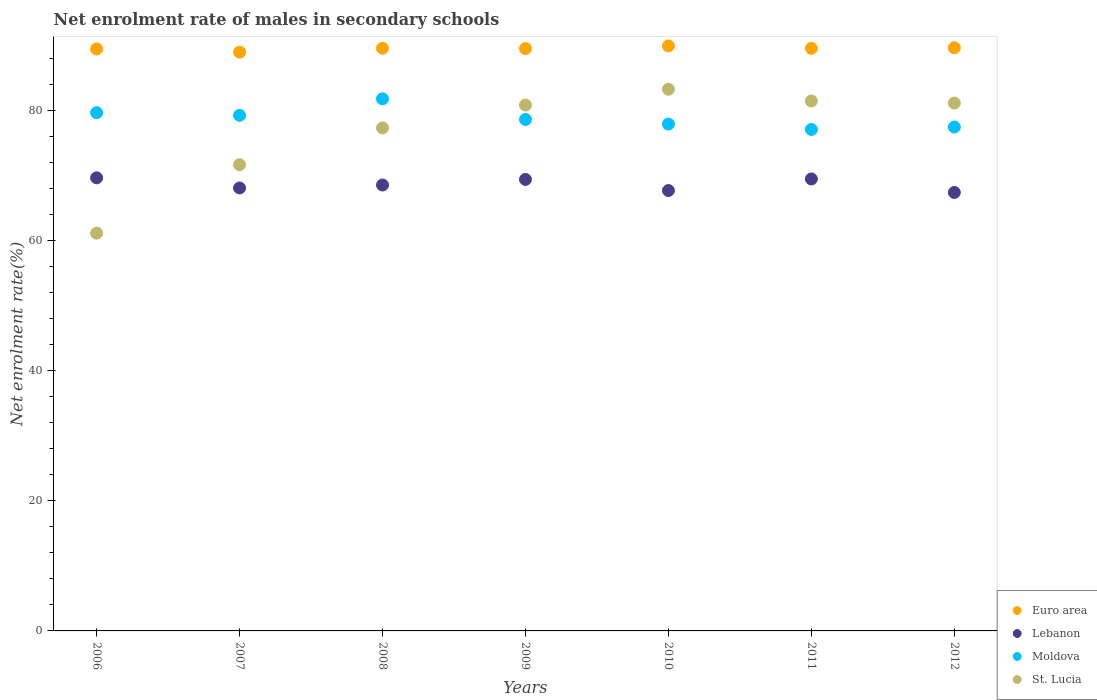Is the number of dotlines equal to the number of legend labels?
Your answer should be very brief. Yes. What is the net enrolment rate of males in secondary schools in Moldova in 2006?
Ensure brevity in your answer.  79.71. Across all years, what is the maximum net enrolment rate of males in secondary schools in Moldova?
Your response must be concise. 81.84. Across all years, what is the minimum net enrolment rate of males in secondary schools in Moldova?
Give a very brief answer. 77.13. What is the total net enrolment rate of males in secondary schools in St. Lucia in the graph?
Offer a very short reply. 537.16. What is the difference between the net enrolment rate of males in secondary schools in St. Lucia in 2007 and that in 2011?
Provide a short and direct response. -9.8. What is the difference between the net enrolment rate of males in secondary schools in Moldova in 2012 and the net enrolment rate of males in secondary schools in St. Lucia in 2010?
Your answer should be compact. -5.82. What is the average net enrolment rate of males in secondary schools in Euro area per year?
Offer a terse response. 89.57. In the year 2009, what is the difference between the net enrolment rate of males in secondary schools in St. Lucia and net enrolment rate of males in secondary schools in Lebanon?
Offer a very short reply. 11.44. What is the ratio of the net enrolment rate of males in secondary schools in Moldova in 2006 to that in 2008?
Your answer should be very brief. 0.97. Is the net enrolment rate of males in secondary schools in Moldova in 2006 less than that in 2011?
Your answer should be compact. No. Is the difference between the net enrolment rate of males in secondary schools in St. Lucia in 2006 and 2011 greater than the difference between the net enrolment rate of males in secondary schools in Lebanon in 2006 and 2011?
Keep it short and to the point. No. What is the difference between the highest and the second highest net enrolment rate of males in secondary schools in St. Lucia?
Provide a short and direct response. 1.81. What is the difference between the highest and the lowest net enrolment rate of males in secondary schools in St. Lucia?
Offer a terse response. 22.14. Is it the case that in every year, the sum of the net enrolment rate of males in secondary schools in Euro area and net enrolment rate of males in secondary schools in Moldova  is greater than the sum of net enrolment rate of males in secondary schools in St. Lucia and net enrolment rate of males in secondary schools in Lebanon?
Your answer should be very brief. Yes. Is it the case that in every year, the sum of the net enrolment rate of males in secondary schools in Lebanon and net enrolment rate of males in secondary schools in St. Lucia  is greater than the net enrolment rate of males in secondary schools in Euro area?
Ensure brevity in your answer.  Yes. Does the net enrolment rate of males in secondary schools in Lebanon monotonically increase over the years?
Your answer should be very brief. No. How many dotlines are there?
Your answer should be compact. 4. Does the graph contain any zero values?
Provide a short and direct response. No. How many legend labels are there?
Provide a succinct answer. 4. What is the title of the graph?
Provide a short and direct response. Net enrolment rate of males in secondary schools. Does "Dominica" appear as one of the legend labels in the graph?
Keep it short and to the point. No. What is the label or title of the Y-axis?
Keep it short and to the point. Net enrolment rate(%). What is the Net enrolment rate(%) of Euro area in 2006?
Provide a short and direct response. 89.52. What is the Net enrolment rate(%) in Lebanon in 2006?
Your answer should be very brief. 69.69. What is the Net enrolment rate(%) in Moldova in 2006?
Ensure brevity in your answer.  79.71. What is the Net enrolment rate(%) in St. Lucia in 2006?
Ensure brevity in your answer.  61.18. What is the Net enrolment rate(%) of Euro area in 2007?
Provide a short and direct response. 89.03. What is the Net enrolment rate(%) in Lebanon in 2007?
Keep it short and to the point. 68.13. What is the Net enrolment rate(%) of Moldova in 2007?
Ensure brevity in your answer.  79.3. What is the Net enrolment rate(%) in St. Lucia in 2007?
Provide a succinct answer. 71.71. What is the Net enrolment rate(%) of Euro area in 2008?
Offer a terse response. 89.62. What is the Net enrolment rate(%) in Lebanon in 2008?
Make the answer very short. 68.59. What is the Net enrolment rate(%) in Moldova in 2008?
Keep it short and to the point. 81.84. What is the Net enrolment rate(%) of St. Lucia in 2008?
Your answer should be compact. 77.37. What is the Net enrolment rate(%) in Euro area in 2009?
Your response must be concise. 89.57. What is the Net enrolment rate(%) of Lebanon in 2009?
Your answer should be very brief. 69.44. What is the Net enrolment rate(%) in Moldova in 2009?
Make the answer very short. 78.67. What is the Net enrolment rate(%) in St. Lucia in 2009?
Your answer should be very brief. 80.89. What is the Net enrolment rate(%) of Euro area in 2010?
Offer a very short reply. 89.98. What is the Net enrolment rate(%) in Lebanon in 2010?
Your answer should be very brief. 67.74. What is the Net enrolment rate(%) of Moldova in 2010?
Your answer should be compact. 77.96. What is the Net enrolment rate(%) of St. Lucia in 2010?
Your answer should be compact. 83.32. What is the Net enrolment rate(%) of Euro area in 2011?
Provide a succinct answer. 89.61. What is the Net enrolment rate(%) of Lebanon in 2011?
Ensure brevity in your answer.  69.52. What is the Net enrolment rate(%) of Moldova in 2011?
Provide a short and direct response. 77.13. What is the Net enrolment rate(%) in St. Lucia in 2011?
Offer a terse response. 81.51. What is the Net enrolment rate(%) of Euro area in 2012?
Offer a very short reply. 89.7. What is the Net enrolment rate(%) in Lebanon in 2012?
Make the answer very short. 67.44. What is the Net enrolment rate(%) in Moldova in 2012?
Provide a short and direct response. 77.5. What is the Net enrolment rate(%) in St. Lucia in 2012?
Ensure brevity in your answer.  81.19. Across all years, what is the maximum Net enrolment rate(%) in Euro area?
Provide a succinct answer. 89.98. Across all years, what is the maximum Net enrolment rate(%) in Lebanon?
Your response must be concise. 69.69. Across all years, what is the maximum Net enrolment rate(%) of Moldova?
Provide a succinct answer. 81.84. Across all years, what is the maximum Net enrolment rate(%) in St. Lucia?
Your response must be concise. 83.32. Across all years, what is the minimum Net enrolment rate(%) of Euro area?
Make the answer very short. 89.03. Across all years, what is the minimum Net enrolment rate(%) in Lebanon?
Provide a short and direct response. 67.44. Across all years, what is the minimum Net enrolment rate(%) in Moldova?
Offer a terse response. 77.13. Across all years, what is the minimum Net enrolment rate(%) of St. Lucia?
Make the answer very short. 61.18. What is the total Net enrolment rate(%) of Euro area in the graph?
Make the answer very short. 627.02. What is the total Net enrolment rate(%) in Lebanon in the graph?
Make the answer very short. 480.55. What is the total Net enrolment rate(%) of Moldova in the graph?
Ensure brevity in your answer.  552.12. What is the total Net enrolment rate(%) in St. Lucia in the graph?
Offer a very short reply. 537.16. What is the difference between the Net enrolment rate(%) in Euro area in 2006 and that in 2007?
Your answer should be very brief. 0.49. What is the difference between the Net enrolment rate(%) of Lebanon in 2006 and that in 2007?
Keep it short and to the point. 1.56. What is the difference between the Net enrolment rate(%) of Moldova in 2006 and that in 2007?
Offer a terse response. 0.41. What is the difference between the Net enrolment rate(%) of St. Lucia in 2006 and that in 2007?
Your response must be concise. -10.53. What is the difference between the Net enrolment rate(%) in Euro area in 2006 and that in 2008?
Your answer should be compact. -0.1. What is the difference between the Net enrolment rate(%) of Lebanon in 2006 and that in 2008?
Make the answer very short. 1.1. What is the difference between the Net enrolment rate(%) of Moldova in 2006 and that in 2008?
Ensure brevity in your answer.  -2.13. What is the difference between the Net enrolment rate(%) of St. Lucia in 2006 and that in 2008?
Your answer should be very brief. -16.19. What is the difference between the Net enrolment rate(%) of Euro area in 2006 and that in 2009?
Your answer should be compact. -0.06. What is the difference between the Net enrolment rate(%) in Lebanon in 2006 and that in 2009?
Your response must be concise. 0.25. What is the difference between the Net enrolment rate(%) of Moldova in 2006 and that in 2009?
Keep it short and to the point. 1.04. What is the difference between the Net enrolment rate(%) in St. Lucia in 2006 and that in 2009?
Your response must be concise. -19.71. What is the difference between the Net enrolment rate(%) in Euro area in 2006 and that in 2010?
Your answer should be compact. -0.46. What is the difference between the Net enrolment rate(%) in Lebanon in 2006 and that in 2010?
Your answer should be very brief. 1.96. What is the difference between the Net enrolment rate(%) of Moldova in 2006 and that in 2010?
Provide a short and direct response. 1.75. What is the difference between the Net enrolment rate(%) in St. Lucia in 2006 and that in 2010?
Your answer should be very brief. -22.14. What is the difference between the Net enrolment rate(%) in Euro area in 2006 and that in 2011?
Make the answer very short. -0.09. What is the difference between the Net enrolment rate(%) in Lebanon in 2006 and that in 2011?
Your answer should be very brief. 0.17. What is the difference between the Net enrolment rate(%) in Moldova in 2006 and that in 2011?
Your answer should be compact. 2.58. What is the difference between the Net enrolment rate(%) of St. Lucia in 2006 and that in 2011?
Keep it short and to the point. -20.32. What is the difference between the Net enrolment rate(%) in Euro area in 2006 and that in 2012?
Keep it short and to the point. -0.18. What is the difference between the Net enrolment rate(%) in Lebanon in 2006 and that in 2012?
Offer a terse response. 2.26. What is the difference between the Net enrolment rate(%) of Moldova in 2006 and that in 2012?
Keep it short and to the point. 2.21. What is the difference between the Net enrolment rate(%) of St. Lucia in 2006 and that in 2012?
Ensure brevity in your answer.  -20.01. What is the difference between the Net enrolment rate(%) in Euro area in 2007 and that in 2008?
Give a very brief answer. -0.59. What is the difference between the Net enrolment rate(%) in Lebanon in 2007 and that in 2008?
Give a very brief answer. -0.46. What is the difference between the Net enrolment rate(%) of Moldova in 2007 and that in 2008?
Offer a terse response. -2.54. What is the difference between the Net enrolment rate(%) of St. Lucia in 2007 and that in 2008?
Provide a succinct answer. -5.66. What is the difference between the Net enrolment rate(%) of Euro area in 2007 and that in 2009?
Your answer should be very brief. -0.55. What is the difference between the Net enrolment rate(%) in Lebanon in 2007 and that in 2009?
Provide a short and direct response. -1.31. What is the difference between the Net enrolment rate(%) in Moldova in 2007 and that in 2009?
Provide a succinct answer. 0.63. What is the difference between the Net enrolment rate(%) of St. Lucia in 2007 and that in 2009?
Your answer should be very brief. -9.18. What is the difference between the Net enrolment rate(%) in Euro area in 2007 and that in 2010?
Your response must be concise. -0.95. What is the difference between the Net enrolment rate(%) of Lebanon in 2007 and that in 2010?
Offer a very short reply. 0.4. What is the difference between the Net enrolment rate(%) of Moldova in 2007 and that in 2010?
Your response must be concise. 1.34. What is the difference between the Net enrolment rate(%) in St. Lucia in 2007 and that in 2010?
Give a very brief answer. -11.61. What is the difference between the Net enrolment rate(%) in Euro area in 2007 and that in 2011?
Offer a terse response. -0.58. What is the difference between the Net enrolment rate(%) of Lebanon in 2007 and that in 2011?
Keep it short and to the point. -1.39. What is the difference between the Net enrolment rate(%) in Moldova in 2007 and that in 2011?
Make the answer very short. 2.17. What is the difference between the Net enrolment rate(%) of St. Lucia in 2007 and that in 2011?
Offer a very short reply. -9.8. What is the difference between the Net enrolment rate(%) in Euro area in 2007 and that in 2012?
Make the answer very short. -0.67. What is the difference between the Net enrolment rate(%) in Lebanon in 2007 and that in 2012?
Offer a very short reply. 0.7. What is the difference between the Net enrolment rate(%) of Moldova in 2007 and that in 2012?
Your answer should be very brief. 1.8. What is the difference between the Net enrolment rate(%) in St. Lucia in 2007 and that in 2012?
Keep it short and to the point. -9.48. What is the difference between the Net enrolment rate(%) in Euro area in 2008 and that in 2009?
Keep it short and to the point. 0.05. What is the difference between the Net enrolment rate(%) of Lebanon in 2008 and that in 2009?
Provide a succinct answer. -0.86. What is the difference between the Net enrolment rate(%) of Moldova in 2008 and that in 2009?
Offer a very short reply. 3.17. What is the difference between the Net enrolment rate(%) of St. Lucia in 2008 and that in 2009?
Provide a short and direct response. -3.52. What is the difference between the Net enrolment rate(%) in Euro area in 2008 and that in 2010?
Your answer should be very brief. -0.36. What is the difference between the Net enrolment rate(%) in Lebanon in 2008 and that in 2010?
Offer a very short reply. 0.85. What is the difference between the Net enrolment rate(%) of Moldova in 2008 and that in 2010?
Provide a succinct answer. 3.88. What is the difference between the Net enrolment rate(%) in St. Lucia in 2008 and that in 2010?
Your answer should be very brief. -5.95. What is the difference between the Net enrolment rate(%) in Euro area in 2008 and that in 2011?
Provide a short and direct response. 0.01. What is the difference between the Net enrolment rate(%) in Lebanon in 2008 and that in 2011?
Your answer should be compact. -0.93. What is the difference between the Net enrolment rate(%) in Moldova in 2008 and that in 2011?
Provide a short and direct response. 4.71. What is the difference between the Net enrolment rate(%) in St. Lucia in 2008 and that in 2011?
Your response must be concise. -4.14. What is the difference between the Net enrolment rate(%) in Euro area in 2008 and that in 2012?
Keep it short and to the point. -0.08. What is the difference between the Net enrolment rate(%) of Lebanon in 2008 and that in 2012?
Ensure brevity in your answer.  1.15. What is the difference between the Net enrolment rate(%) in Moldova in 2008 and that in 2012?
Your answer should be very brief. 4.34. What is the difference between the Net enrolment rate(%) in St. Lucia in 2008 and that in 2012?
Your answer should be very brief. -3.82. What is the difference between the Net enrolment rate(%) in Euro area in 2009 and that in 2010?
Ensure brevity in your answer.  -0.4. What is the difference between the Net enrolment rate(%) in Lebanon in 2009 and that in 2010?
Give a very brief answer. 1.71. What is the difference between the Net enrolment rate(%) of Moldova in 2009 and that in 2010?
Your response must be concise. 0.71. What is the difference between the Net enrolment rate(%) of St. Lucia in 2009 and that in 2010?
Offer a very short reply. -2.43. What is the difference between the Net enrolment rate(%) of Euro area in 2009 and that in 2011?
Your response must be concise. -0.04. What is the difference between the Net enrolment rate(%) of Lebanon in 2009 and that in 2011?
Provide a short and direct response. -0.07. What is the difference between the Net enrolment rate(%) of Moldova in 2009 and that in 2011?
Offer a very short reply. 1.54. What is the difference between the Net enrolment rate(%) in St. Lucia in 2009 and that in 2011?
Make the answer very short. -0.62. What is the difference between the Net enrolment rate(%) of Euro area in 2009 and that in 2012?
Provide a succinct answer. -0.12. What is the difference between the Net enrolment rate(%) of Lebanon in 2009 and that in 2012?
Give a very brief answer. 2.01. What is the difference between the Net enrolment rate(%) of Moldova in 2009 and that in 2012?
Your answer should be compact. 1.16. What is the difference between the Net enrolment rate(%) of St. Lucia in 2009 and that in 2012?
Offer a very short reply. -0.3. What is the difference between the Net enrolment rate(%) of Euro area in 2010 and that in 2011?
Your answer should be very brief. 0.37. What is the difference between the Net enrolment rate(%) in Lebanon in 2010 and that in 2011?
Your answer should be compact. -1.78. What is the difference between the Net enrolment rate(%) in Moldova in 2010 and that in 2011?
Offer a terse response. 0.83. What is the difference between the Net enrolment rate(%) in St. Lucia in 2010 and that in 2011?
Offer a very short reply. 1.81. What is the difference between the Net enrolment rate(%) in Euro area in 2010 and that in 2012?
Provide a short and direct response. 0.28. What is the difference between the Net enrolment rate(%) of Lebanon in 2010 and that in 2012?
Provide a succinct answer. 0.3. What is the difference between the Net enrolment rate(%) in Moldova in 2010 and that in 2012?
Make the answer very short. 0.46. What is the difference between the Net enrolment rate(%) of St. Lucia in 2010 and that in 2012?
Your response must be concise. 2.13. What is the difference between the Net enrolment rate(%) in Euro area in 2011 and that in 2012?
Keep it short and to the point. -0.09. What is the difference between the Net enrolment rate(%) of Lebanon in 2011 and that in 2012?
Make the answer very short. 2.08. What is the difference between the Net enrolment rate(%) in Moldova in 2011 and that in 2012?
Provide a succinct answer. -0.37. What is the difference between the Net enrolment rate(%) of St. Lucia in 2011 and that in 2012?
Make the answer very short. 0.31. What is the difference between the Net enrolment rate(%) in Euro area in 2006 and the Net enrolment rate(%) in Lebanon in 2007?
Your response must be concise. 21.38. What is the difference between the Net enrolment rate(%) in Euro area in 2006 and the Net enrolment rate(%) in Moldova in 2007?
Offer a terse response. 10.22. What is the difference between the Net enrolment rate(%) in Euro area in 2006 and the Net enrolment rate(%) in St. Lucia in 2007?
Your response must be concise. 17.81. What is the difference between the Net enrolment rate(%) in Lebanon in 2006 and the Net enrolment rate(%) in Moldova in 2007?
Your answer should be very brief. -9.61. What is the difference between the Net enrolment rate(%) of Lebanon in 2006 and the Net enrolment rate(%) of St. Lucia in 2007?
Offer a terse response. -2.02. What is the difference between the Net enrolment rate(%) in Moldova in 2006 and the Net enrolment rate(%) in St. Lucia in 2007?
Offer a terse response. 8. What is the difference between the Net enrolment rate(%) in Euro area in 2006 and the Net enrolment rate(%) in Lebanon in 2008?
Provide a short and direct response. 20.93. What is the difference between the Net enrolment rate(%) of Euro area in 2006 and the Net enrolment rate(%) of Moldova in 2008?
Provide a succinct answer. 7.68. What is the difference between the Net enrolment rate(%) of Euro area in 2006 and the Net enrolment rate(%) of St. Lucia in 2008?
Make the answer very short. 12.15. What is the difference between the Net enrolment rate(%) in Lebanon in 2006 and the Net enrolment rate(%) in Moldova in 2008?
Provide a short and direct response. -12.15. What is the difference between the Net enrolment rate(%) of Lebanon in 2006 and the Net enrolment rate(%) of St. Lucia in 2008?
Offer a terse response. -7.67. What is the difference between the Net enrolment rate(%) of Moldova in 2006 and the Net enrolment rate(%) of St. Lucia in 2008?
Ensure brevity in your answer.  2.34. What is the difference between the Net enrolment rate(%) of Euro area in 2006 and the Net enrolment rate(%) of Lebanon in 2009?
Keep it short and to the point. 20.07. What is the difference between the Net enrolment rate(%) of Euro area in 2006 and the Net enrolment rate(%) of Moldova in 2009?
Keep it short and to the point. 10.85. What is the difference between the Net enrolment rate(%) in Euro area in 2006 and the Net enrolment rate(%) in St. Lucia in 2009?
Ensure brevity in your answer.  8.63. What is the difference between the Net enrolment rate(%) of Lebanon in 2006 and the Net enrolment rate(%) of Moldova in 2009?
Your answer should be compact. -8.98. What is the difference between the Net enrolment rate(%) of Lebanon in 2006 and the Net enrolment rate(%) of St. Lucia in 2009?
Provide a succinct answer. -11.19. What is the difference between the Net enrolment rate(%) in Moldova in 2006 and the Net enrolment rate(%) in St. Lucia in 2009?
Provide a succinct answer. -1.18. What is the difference between the Net enrolment rate(%) in Euro area in 2006 and the Net enrolment rate(%) in Lebanon in 2010?
Give a very brief answer. 21.78. What is the difference between the Net enrolment rate(%) of Euro area in 2006 and the Net enrolment rate(%) of Moldova in 2010?
Offer a very short reply. 11.56. What is the difference between the Net enrolment rate(%) in Euro area in 2006 and the Net enrolment rate(%) in St. Lucia in 2010?
Offer a very short reply. 6.2. What is the difference between the Net enrolment rate(%) of Lebanon in 2006 and the Net enrolment rate(%) of Moldova in 2010?
Provide a short and direct response. -8.27. What is the difference between the Net enrolment rate(%) in Lebanon in 2006 and the Net enrolment rate(%) in St. Lucia in 2010?
Ensure brevity in your answer.  -13.63. What is the difference between the Net enrolment rate(%) of Moldova in 2006 and the Net enrolment rate(%) of St. Lucia in 2010?
Make the answer very short. -3.61. What is the difference between the Net enrolment rate(%) of Euro area in 2006 and the Net enrolment rate(%) of Lebanon in 2011?
Provide a short and direct response. 20. What is the difference between the Net enrolment rate(%) in Euro area in 2006 and the Net enrolment rate(%) in Moldova in 2011?
Ensure brevity in your answer.  12.38. What is the difference between the Net enrolment rate(%) of Euro area in 2006 and the Net enrolment rate(%) of St. Lucia in 2011?
Make the answer very short. 8.01. What is the difference between the Net enrolment rate(%) of Lebanon in 2006 and the Net enrolment rate(%) of Moldova in 2011?
Your response must be concise. -7.44. What is the difference between the Net enrolment rate(%) in Lebanon in 2006 and the Net enrolment rate(%) in St. Lucia in 2011?
Offer a very short reply. -11.81. What is the difference between the Net enrolment rate(%) in Moldova in 2006 and the Net enrolment rate(%) in St. Lucia in 2011?
Your response must be concise. -1.8. What is the difference between the Net enrolment rate(%) of Euro area in 2006 and the Net enrolment rate(%) of Lebanon in 2012?
Offer a terse response. 22.08. What is the difference between the Net enrolment rate(%) of Euro area in 2006 and the Net enrolment rate(%) of Moldova in 2012?
Ensure brevity in your answer.  12.01. What is the difference between the Net enrolment rate(%) in Euro area in 2006 and the Net enrolment rate(%) in St. Lucia in 2012?
Make the answer very short. 8.32. What is the difference between the Net enrolment rate(%) of Lebanon in 2006 and the Net enrolment rate(%) of Moldova in 2012?
Offer a terse response. -7.81. What is the difference between the Net enrolment rate(%) in Lebanon in 2006 and the Net enrolment rate(%) in St. Lucia in 2012?
Your answer should be very brief. -11.5. What is the difference between the Net enrolment rate(%) of Moldova in 2006 and the Net enrolment rate(%) of St. Lucia in 2012?
Ensure brevity in your answer.  -1.48. What is the difference between the Net enrolment rate(%) of Euro area in 2007 and the Net enrolment rate(%) of Lebanon in 2008?
Provide a succinct answer. 20.44. What is the difference between the Net enrolment rate(%) of Euro area in 2007 and the Net enrolment rate(%) of Moldova in 2008?
Your answer should be very brief. 7.19. What is the difference between the Net enrolment rate(%) of Euro area in 2007 and the Net enrolment rate(%) of St. Lucia in 2008?
Make the answer very short. 11.66. What is the difference between the Net enrolment rate(%) in Lebanon in 2007 and the Net enrolment rate(%) in Moldova in 2008?
Your response must be concise. -13.71. What is the difference between the Net enrolment rate(%) in Lebanon in 2007 and the Net enrolment rate(%) in St. Lucia in 2008?
Ensure brevity in your answer.  -9.24. What is the difference between the Net enrolment rate(%) of Moldova in 2007 and the Net enrolment rate(%) of St. Lucia in 2008?
Your response must be concise. 1.93. What is the difference between the Net enrolment rate(%) in Euro area in 2007 and the Net enrolment rate(%) in Lebanon in 2009?
Provide a succinct answer. 19.58. What is the difference between the Net enrolment rate(%) in Euro area in 2007 and the Net enrolment rate(%) in Moldova in 2009?
Give a very brief answer. 10.36. What is the difference between the Net enrolment rate(%) in Euro area in 2007 and the Net enrolment rate(%) in St. Lucia in 2009?
Your answer should be very brief. 8.14. What is the difference between the Net enrolment rate(%) of Lebanon in 2007 and the Net enrolment rate(%) of Moldova in 2009?
Your answer should be compact. -10.54. What is the difference between the Net enrolment rate(%) of Lebanon in 2007 and the Net enrolment rate(%) of St. Lucia in 2009?
Your answer should be very brief. -12.76. What is the difference between the Net enrolment rate(%) in Moldova in 2007 and the Net enrolment rate(%) in St. Lucia in 2009?
Give a very brief answer. -1.59. What is the difference between the Net enrolment rate(%) in Euro area in 2007 and the Net enrolment rate(%) in Lebanon in 2010?
Offer a very short reply. 21.29. What is the difference between the Net enrolment rate(%) of Euro area in 2007 and the Net enrolment rate(%) of Moldova in 2010?
Provide a succinct answer. 11.07. What is the difference between the Net enrolment rate(%) of Euro area in 2007 and the Net enrolment rate(%) of St. Lucia in 2010?
Give a very brief answer. 5.71. What is the difference between the Net enrolment rate(%) of Lebanon in 2007 and the Net enrolment rate(%) of Moldova in 2010?
Give a very brief answer. -9.83. What is the difference between the Net enrolment rate(%) in Lebanon in 2007 and the Net enrolment rate(%) in St. Lucia in 2010?
Provide a short and direct response. -15.19. What is the difference between the Net enrolment rate(%) in Moldova in 2007 and the Net enrolment rate(%) in St. Lucia in 2010?
Your answer should be very brief. -4.02. What is the difference between the Net enrolment rate(%) in Euro area in 2007 and the Net enrolment rate(%) in Lebanon in 2011?
Provide a succinct answer. 19.51. What is the difference between the Net enrolment rate(%) of Euro area in 2007 and the Net enrolment rate(%) of Moldova in 2011?
Provide a short and direct response. 11.89. What is the difference between the Net enrolment rate(%) of Euro area in 2007 and the Net enrolment rate(%) of St. Lucia in 2011?
Give a very brief answer. 7.52. What is the difference between the Net enrolment rate(%) of Lebanon in 2007 and the Net enrolment rate(%) of Moldova in 2011?
Ensure brevity in your answer.  -9. What is the difference between the Net enrolment rate(%) in Lebanon in 2007 and the Net enrolment rate(%) in St. Lucia in 2011?
Make the answer very short. -13.37. What is the difference between the Net enrolment rate(%) in Moldova in 2007 and the Net enrolment rate(%) in St. Lucia in 2011?
Offer a terse response. -2.21. What is the difference between the Net enrolment rate(%) in Euro area in 2007 and the Net enrolment rate(%) in Lebanon in 2012?
Give a very brief answer. 21.59. What is the difference between the Net enrolment rate(%) of Euro area in 2007 and the Net enrolment rate(%) of Moldova in 2012?
Offer a very short reply. 11.52. What is the difference between the Net enrolment rate(%) in Euro area in 2007 and the Net enrolment rate(%) in St. Lucia in 2012?
Your response must be concise. 7.83. What is the difference between the Net enrolment rate(%) of Lebanon in 2007 and the Net enrolment rate(%) of Moldova in 2012?
Your response must be concise. -9.37. What is the difference between the Net enrolment rate(%) in Lebanon in 2007 and the Net enrolment rate(%) in St. Lucia in 2012?
Your answer should be very brief. -13.06. What is the difference between the Net enrolment rate(%) in Moldova in 2007 and the Net enrolment rate(%) in St. Lucia in 2012?
Your answer should be compact. -1.89. What is the difference between the Net enrolment rate(%) of Euro area in 2008 and the Net enrolment rate(%) of Lebanon in 2009?
Provide a succinct answer. 20.17. What is the difference between the Net enrolment rate(%) in Euro area in 2008 and the Net enrolment rate(%) in Moldova in 2009?
Make the answer very short. 10.95. What is the difference between the Net enrolment rate(%) of Euro area in 2008 and the Net enrolment rate(%) of St. Lucia in 2009?
Provide a short and direct response. 8.73. What is the difference between the Net enrolment rate(%) in Lebanon in 2008 and the Net enrolment rate(%) in Moldova in 2009?
Give a very brief answer. -10.08. What is the difference between the Net enrolment rate(%) of Lebanon in 2008 and the Net enrolment rate(%) of St. Lucia in 2009?
Ensure brevity in your answer.  -12.3. What is the difference between the Net enrolment rate(%) in Moldova in 2008 and the Net enrolment rate(%) in St. Lucia in 2009?
Give a very brief answer. 0.95. What is the difference between the Net enrolment rate(%) in Euro area in 2008 and the Net enrolment rate(%) in Lebanon in 2010?
Ensure brevity in your answer.  21.88. What is the difference between the Net enrolment rate(%) of Euro area in 2008 and the Net enrolment rate(%) of Moldova in 2010?
Ensure brevity in your answer.  11.66. What is the difference between the Net enrolment rate(%) in Euro area in 2008 and the Net enrolment rate(%) in St. Lucia in 2010?
Provide a short and direct response. 6.3. What is the difference between the Net enrolment rate(%) of Lebanon in 2008 and the Net enrolment rate(%) of Moldova in 2010?
Provide a short and direct response. -9.37. What is the difference between the Net enrolment rate(%) in Lebanon in 2008 and the Net enrolment rate(%) in St. Lucia in 2010?
Provide a short and direct response. -14.73. What is the difference between the Net enrolment rate(%) in Moldova in 2008 and the Net enrolment rate(%) in St. Lucia in 2010?
Ensure brevity in your answer.  -1.48. What is the difference between the Net enrolment rate(%) of Euro area in 2008 and the Net enrolment rate(%) of Lebanon in 2011?
Your answer should be very brief. 20.1. What is the difference between the Net enrolment rate(%) in Euro area in 2008 and the Net enrolment rate(%) in Moldova in 2011?
Provide a succinct answer. 12.49. What is the difference between the Net enrolment rate(%) in Euro area in 2008 and the Net enrolment rate(%) in St. Lucia in 2011?
Your answer should be very brief. 8.11. What is the difference between the Net enrolment rate(%) in Lebanon in 2008 and the Net enrolment rate(%) in Moldova in 2011?
Offer a terse response. -8.54. What is the difference between the Net enrolment rate(%) of Lebanon in 2008 and the Net enrolment rate(%) of St. Lucia in 2011?
Provide a succinct answer. -12.92. What is the difference between the Net enrolment rate(%) of Moldova in 2008 and the Net enrolment rate(%) of St. Lucia in 2011?
Ensure brevity in your answer.  0.33. What is the difference between the Net enrolment rate(%) in Euro area in 2008 and the Net enrolment rate(%) in Lebanon in 2012?
Give a very brief answer. 22.18. What is the difference between the Net enrolment rate(%) in Euro area in 2008 and the Net enrolment rate(%) in Moldova in 2012?
Keep it short and to the point. 12.11. What is the difference between the Net enrolment rate(%) in Euro area in 2008 and the Net enrolment rate(%) in St. Lucia in 2012?
Keep it short and to the point. 8.43. What is the difference between the Net enrolment rate(%) of Lebanon in 2008 and the Net enrolment rate(%) of Moldova in 2012?
Your answer should be very brief. -8.92. What is the difference between the Net enrolment rate(%) of Lebanon in 2008 and the Net enrolment rate(%) of St. Lucia in 2012?
Ensure brevity in your answer.  -12.6. What is the difference between the Net enrolment rate(%) in Moldova in 2008 and the Net enrolment rate(%) in St. Lucia in 2012?
Offer a terse response. 0.65. What is the difference between the Net enrolment rate(%) in Euro area in 2009 and the Net enrolment rate(%) in Lebanon in 2010?
Offer a very short reply. 21.84. What is the difference between the Net enrolment rate(%) in Euro area in 2009 and the Net enrolment rate(%) in Moldova in 2010?
Keep it short and to the point. 11.61. What is the difference between the Net enrolment rate(%) of Euro area in 2009 and the Net enrolment rate(%) of St. Lucia in 2010?
Make the answer very short. 6.25. What is the difference between the Net enrolment rate(%) of Lebanon in 2009 and the Net enrolment rate(%) of Moldova in 2010?
Provide a short and direct response. -8.52. What is the difference between the Net enrolment rate(%) in Lebanon in 2009 and the Net enrolment rate(%) in St. Lucia in 2010?
Your answer should be very brief. -13.88. What is the difference between the Net enrolment rate(%) of Moldova in 2009 and the Net enrolment rate(%) of St. Lucia in 2010?
Provide a succinct answer. -4.65. What is the difference between the Net enrolment rate(%) in Euro area in 2009 and the Net enrolment rate(%) in Lebanon in 2011?
Offer a terse response. 20.05. What is the difference between the Net enrolment rate(%) of Euro area in 2009 and the Net enrolment rate(%) of Moldova in 2011?
Your answer should be very brief. 12.44. What is the difference between the Net enrolment rate(%) of Euro area in 2009 and the Net enrolment rate(%) of St. Lucia in 2011?
Keep it short and to the point. 8.07. What is the difference between the Net enrolment rate(%) in Lebanon in 2009 and the Net enrolment rate(%) in Moldova in 2011?
Provide a short and direct response. -7.69. What is the difference between the Net enrolment rate(%) in Lebanon in 2009 and the Net enrolment rate(%) in St. Lucia in 2011?
Provide a succinct answer. -12.06. What is the difference between the Net enrolment rate(%) of Moldova in 2009 and the Net enrolment rate(%) of St. Lucia in 2011?
Your answer should be very brief. -2.84. What is the difference between the Net enrolment rate(%) of Euro area in 2009 and the Net enrolment rate(%) of Lebanon in 2012?
Ensure brevity in your answer.  22.14. What is the difference between the Net enrolment rate(%) of Euro area in 2009 and the Net enrolment rate(%) of Moldova in 2012?
Give a very brief answer. 12.07. What is the difference between the Net enrolment rate(%) of Euro area in 2009 and the Net enrolment rate(%) of St. Lucia in 2012?
Your response must be concise. 8.38. What is the difference between the Net enrolment rate(%) in Lebanon in 2009 and the Net enrolment rate(%) in Moldova in 2012?
Ensure brevity in your answer.  -8.06. What is the difference between the Net enrolment rate(%) in Lebanon in 2009 and the Net enrolment rate(%) in St. Lucia in 2012?
Keep it short and to the point. -11.75. What is the difference between the Net enrolment rate(%) of Moldova in 2009 and the Net enrolment rate(%) of St. Lucia in 2012?
Provide a short and direct response. -2.52. What is the difference between the Net enrolment rate(%) in Euro area in 2010 and the Net enrolment rate(%) in Lebanon in 2011?
Your answer should be very brief. 20.46. What is the difference between the Net enrolment rate(%) in Euro area in 2010 and the Net enrolment rate(%) in Moldova in 2011?
Your answer should be very brief. 12.85. What is the difference between the Net enrolment rate(%) of Euro area in 2010 and the Net enrolment rate(%) of St. Lucia in 2011?
Offer a terse response. 8.47. What is the difference between the Net enrolment rate(%) in Lebanon in 2010 and the Net enrolment rate(%) in Moldova in 2011?
Your response must be concise. -9.4. What is the difference between the Net enrolment rate(%) in Lebanon in 2010 and the Net enrolment rate(%) in St. Lucia in 2011?
Your response must be concise. -13.77. What is the difference between the Net enrolment rate(%) of Moldova in 2010 and the Net enrolment rate(%) of St. Lucia in 2011?
Your answer should be very brief. -3.55. What is the difference between the Net enrolment rate(%) of Euro area in 2010 and the Net enrolment rate(%) of Lebanon in 2012?
Keep it short and to the point. 22.54. What is the difference between the Net enrolment rate(%) in Euro area in 2010 and the Net enrolment rate(%) in Moldova in 2012?
Your answer should be compact. 12.47. What is the difference between the Net enrolment rate(%) of Euro area in 2010 and the Net enrolment rate(%) of St. Lucia in 2012?
Your response must be concise. 8.79. What is the difference between the Net enrolment rate(%) in Lebanon in 2010 and the Net enrolment rate(%) in Moldova in 2012?
Ensure brevity in your answer.  -9.77. What is the difference between the Net enrolment rate(%) in Lebanon in 2010 and the Net enrolment rate(%) in St. Lucia in 2012?
Keep it short and to the point. -13.46. What is the difference between the Net enrolment rate(%) of Moldova in 2010 and the Net enrolment rate(%) of St. Lucia in 2012?
Your response must be concise. -3.23. What is the difference between the Net enrolment rate(%) in Euro area in 2011 and the Net enrolment rate(%) in Lebanon in 2012?
Give a very brief answer. 22.17. What is the difference between the Net enrolment rate(%) of Euro area in 2011 and the Net enrolment rate(%) of Moldova in 2012?
Keep it short and to the point. 12.1. What is the difference between the Net enrolment rate(%) in Euro area in 2011 and the Net enrolment rate(%) in St. Lucia in 2012?
Give a very brief answer. 8.42. What is the difference between the Net enrolment rate(%) in Lebanon in 2011 and the Net enrolment rate(%) in Moldova in 2012?
Ensure brevity in your answer.  -7.99. What is the difference between the Net enrolment rate(%) of Lebanon in 2011 and the Net enrolment rate(%) of St. Lucia in 2012?
Your answer should be very brief. -11.67. What is the difference between the Net enrolment rate(%) in Moldova in 2011 and the Net enrolment rate(%) in St. Lucia in 2012?
Make the answer very short. -4.06. What is the average Net enrolment rate(%) of Euro area per year?
Offer a very short reply. 89.57. What is the average Net enrolment rate(%) in Lebanon per year?
Make the answer very short. 68.65. What is the average Net enrolment rate(%) in Moldova per year?
Provide a short and direct response. 78.87. What is the average Net enrolment rate(%) in St. Lucia per year?
Ensure brevity in your answer.  76.74. In the year 2006, what is the difference between the Net enrolment rate(%) of Euro area and Net enrolment rate(%) of Lebanon?
Provide a succinct answer. 19.82. In the year 2006, what is the difference between the Net enrolment rate(%) of Euro area and Net enrolment rate(%) of Moldova?
Your answer should be very brief. 9.81. In the year 2006, what is the difference between the Net enrolment rate(%) of Euro area and Net enrolment rate(%) of St. Lucia?
Offer a very short reply. 28.33. In the year 2006, what is the difference between the Net enrolment rate(%) of Lebanon and Net enrolment rate(%) of Moldova?
Keep it short and to the point. -10.02. In the year 2006, what is the difference between the Net enrolment rate(%) in Lebanon and Net enrolment rate(%) in St. Lucia?
Provide a succinct answer. 8.51. In the year 2006, what is the difference between the Net enrolment rate(%) in Moldova and Net enrolment rate(%) in St. Lucia?
Your answer should be very brief. 18.53. In the year 2007, what is the difference between the Net enrolment rate(%) in Euro area and Net enrolment rate(%) in Lebanon?
Your answer should be very brief. 20.89. In the year 2007, what is the difference between the Net enrolment rate(%) of Euro area and Net enrolment rate(%) of Moldova?
Give a very brief answer. 9.73. In the year 2007, what is the difference between the Net enrolment rate(%) in Euro area and Net enrolment rate(%) in St. Lucia?
Make the answer very short. 17.32. In the year 2007, what is the difference between the Net enrolment rate(%) in Lebanon and Net enrolment rate(%) in Moldova?
Ensure brevity in your answer.  -11.17. In the year 2007, what is the difference between the Net enrolment rate(%) of Lebanon and Net enrolment rate(%) of St. Lucia?
Provide a succinct answer. -3.58. In the year 2007, what is the difference between the Net enrolment rate(%) of Moldova and Net enrolment rate(%) of St. Lucia?
Provide a succinct answer. 7.59. In the year 2008, what is the difference between the Net enrolment rate(%) in Euro area and Net enrolment rate(%) in Lebanon?
Provide a short and direct response. 21.03. In the year 2008, what is the difference between the Net enrolment rate(%) in Euro area and Net enrolment rate(%) in Moldova?
Offer a very short reply. 7.78. In the year 2008, what is the difference between the Net enrolment rate(%) in Euro area and Net enrolment rate(%) in St. Lucia?
Your response must be concise. 12.25. In the year 2008, what is the difference between the Net enrolment rate(%) of Lebanon and Net enrolment rate(%) of Moldova?
Provide a succinct answer. -13.25. In the year 2008, what is the difference between the Net enrolment rate(%) of Lebanon and Net enrolment rate(%) of St. Lucia?
Offer a terse response. -8.78. In the year 2008, what is the difference between the Net enrolment rate(%) in Moldova and Net enrolment rate(%) in St. Lucia?
Give a very brief answer. 4.47. In the year 2009, what is the difference between the Net enrolment rate(%) in Euro area and Net enrolment rate(%) in Lebanon?
Your response must be concise. 20.13. In the year 2009, what is the difference between the Net enrolment rate(%) of Euro area and Net enrolment rate(%) of Moldova?
Make the answer very short. 10.9. In the year 2009, what is the difference between the Net enrolment rate(%) of Euro area and Net enrolment rate(%) of St. Lucia?
Offer a terse response. 8.69. In the year 2009, what is the difference between the Net enrolment rate(%) of Lebanon and Net enrolment rate(%) of Moldova?
Your answer should be compact. -9.22. In the year 2009, what is the difference between the Net enrolment rate(%) in Lebanon and Net enrolment rate(%) in St. Lucia?
Your answer should be compact. -11.44. In the year 2009, what is the difference between the Net enrolment rate(%) in Moldova and Net enrolment rate(%) in St. Lucia?
Your answer should be very brief. -2.22. In the year 2010, what is the difference between the Net enrolment rate(%) of Euro area and Net enrolment rate(%) of Lebanon?
Make the answer very short. 22.24. In the year 2010, what is the difference between the Net enrolment rate(%) in Euro area and Net enrolment rate(%) in Moldova?
Provide a short and direct response. 12.02. In the year 2010, what is the difference between the Net enrolment rate(%) in Euro area and Net enrolment rate(%) in St. Lucia?
Your answer should be very brief. 6.66. In the year 2010, what is the difference between the Net enrolment rate(%) of Lebanon and Net enrolment rate(%) of Moldova?
Make the answer very short. -10.22. In the year 2010, what is the difference between the Net enrolment rate(%) in Lebanon and Net enrolment rate(%) in St. Lucia?
Provide a succinct answer. -15.58. In the year 2010, what is the difference between the Net enrolment rate(%) of Moldova and Net enrolment rate(%) of St. Lucia?
Give a very brief answer. -5.36. In the year 2011, what is the difference between the Net enrolment rate(%) of Euro area and Net enrolment rate(%) of Lebanon?
Your answer should be very brief. 20.09. In the year 2011, what is the difference between the Net enrolment rate(%) in Euro area and Net enrolment rate(%) in Moldova?
Provide a succinct answer. 12.48. In the year 2011, what is the difference between the Net enrolment rate(%) in Euro area and Net enrolment rate(%) in St. Lucia?
Provide a succinct answer. 8.1. In the year 2011, what is the difference between the Net enrolment rate(%) of Lebanon and Net enrolment rate(%) of Moldova?
Your answer should be very brief. -7.61. In the year 2011, what is the difference between the Net enrolment rate(%) in Lebanon and Net enrolment rate(%) in St. Lucia?
Offer a terse response. -11.99. In the year 2011, what is the difference between the Net enrolment rate(%) of Moldova and Net enrolment rate(%) of St. Lucia?
Your answer should be very brief. -4.37. In the year 2012, what is the difference between the Net enrolment rate(%) in Euro area and Net enrolment rate(%) in Lebanon?
Make the answer very short. 22.26. In the year 2012, what is the difference between the Net enrolment rate(%) of Euro area and Net enrolment rate(%) of Moldova?
Ensure brevity in your answer.  12.19. In the year 2012, what is the difference between the Net enrolment rate(%) of Euro area and Net enrolment rate(%) of St. Lucia?
Keep it short and to the point. 8.5. In the year 2012, what is the difference between the Net enrolment rate(%) of Lebanon and Net enrolment rate(%) of Moldova?
Make the answer very short. -10.07. In the year 2012, what is the difference between the Net enrolment rate(%) in Lebanon and Net enrolment rate(%) in St. Lucia?
Offer a terse response. -13.75. In the year 2012, what is the difference between the Net enrolment rate(%) of Moldova and Net enrolment rate(%) of St. Lucia?
Offer a terse response. -3.69. What is the ratio of the Net enrolment rate(%) in Euro area in 2006 to that in 2007?
Offer a terse response. 1.01. What is the ratio of the Net enrolment rate(%) in Lebanon in 2006 to that in 2007?
Ensure brevity in your answer.  1.02. What is the ratio of the Net enrolment rate(%) of St. Lucia in 2006 to that in 2007?
Offer a very short reply. 0.85. What is the ratio of the Net enrolment rate(%) of Euro area in 2006 to that in 2008?
Provide a short and direct response. 1. What is the ratio of the Net enrolment rate(%) in Lebanon in 2006 to that in 2008?
Ensure brevity in your answer.  1.02. What is the ratio of the Net enrolment rate(%) in St. Lucia in 2006 to that in 2008?
Keep it short and to the point. 0.79. What is the ratio of the Net enrolment rate(%) of Moldova in 2006 to that in 2009?
Keep it short and to the point. 1.01. What is the ratio of the Net enrolment rate(%) of St. Lucia in 2006 to that in 2009?
Your response must be concise. 0.76. What is the ratio of the Net enrolment rate(%) in Lebanon in 2006 to that in 2010?
Provide a short and direct response. 1.03. What is the ratio of the Net enrolment rate(%) in Moldova in 2006 to that in 2010?
Make the answer very short. 1.02. What is the ratio of the Net enrolment rate(%) of St. Lucia in 2006 to that in 2010?
Offer a very short reply. 0.73. What is the ratio of the Net enrolment rate(%) in Lebanon in 2006 to that in 2011?
Ensure brevity in your answer.  1. What is the ratio of the Net enrolment rate(%) in Moldova in 2006 to that in 2011?
Ensure brevity in your answer.  1.03. What is the ratio of the Net enrolment rate(%) of St. Lucia in 2006 to that in 2011?
Give a very brief answer. 0.75. What is the ratio of the Net enrolment rate(%) in Lebanon in 2006 to that in 2012?
Your answer should be compact. 1.03. What is the ratio of the Net enrolment rate(%) in Moldova in 2006 to that in 2012?
Provide a succinct answer. 1.03. What is the ratio of the Net enrolment rate(%) of St. Lucia in 2006 to that in 2012?
Give a very brief answer. 0.75. What is the ratio of the Net enrolment rate(%) of Euro area in 2007 to that in 2008?
Offer a terse response. 0.99. What is the ratio of the Net enrolment rate(%) in Lebanon in 2007 to that in 2008?
Your answer should be compact. 0.99. What is the ratio of the Net enrolment rate(%) of St. Lucia in 2007 to that in 2008?
Provide a succinct answer. 0.93. What is the ratio of the Net enrolment rate(%) in Euro area in 2007 to that in 2009?
Your answer should be very brief. 0.99. What is the ratio of the Net enrolment rate(%) of Lebanon in 2007 to that in 2009?
Your response must be concise. 0.98. What is the ratio of the Net enrolment rate(%) of St. Lucia in 2007 to that in 2009?
Give a very brief answer. 0.89. What is the ratio of the Net enrolment rate(%) in Lebanon in 2007 to that in 2010?
Provide a short and direct response. 1.01. What is the ratio of the Net enrolment rate(%) of Moldova in 2007 to that in 2010?
Provide a succinct answer. 1.02. What is the ratio of the Net enrolment rate(%) in St. Lucia in 2007 to that in 2010?
Your answer should be compact. 0.86. What is the ratio of the Net enrolment rate(%) in Lebanon in 2007 to that in 2011?
Offer a terse response. 0.98. What is the ratio of the Net enrolment rate(%) of Moldova in 2007 to that in 2011?
Provide a short and direct response. 1.03. What is the ratio of the Net enrolment rate(%) of St. Lucia in 2007 to that in 2011?
Ensure brevity in your answer.  0.88. What is the ratio of the Net enrolment rate(%) in Euro area in 2007 to that in 2012?
Provide a short and direct response. 0.99. What is the ratio of the Net enrolment rate(%) of Lebanon in 2007 to that in 2012?
Your response must be concise. 1.01. What is the ratio of the Net enrolment rate(%) in Moldova in 2007 to that in 2012?
Your answer should be very brief. 1.02. What is the ratio of the Net enrolment rate(%) in St. Lucia in 2007 to that in 2012?
Ensure brevity in your answer.  0.88. What is the ratio of the Net enrolment rate(%) of Euro area in 2008 to that in 2009?
Your response must be concise. 1. What is the ratio of the Net enrolment rate(%) in Lebanon in 2008 to that in 2009?
Your answer should be compact. 0.99. What is the ratio of the Net enrolment rate(%) of Moldova in 2008 to that in 2009?
Ensure brevity in your answer.  1.04. What is the ratio of the Net enrolment rate(%) of St. Lucia in 2008 to that in 2009?
Provide a short and direct response. 0.96. What is the ratio of the Net enrolment rate(%) in Euro area in 2008 to that in 2010?
Provide a succinct answer. 1. What is the ratio of the Net enrolment rate(%) in Lebanon in 2008 to that in 2010?
Your answer should be compact. 1.01. What is the ratio of the Net enrolment rate(%) of Moldova in 2008 to that in 2010?
Your answer should be compact. 1.05. What is the ratio of the Net enrolment rate(%) in Euro area in 2008 to that in 2011?
Provide a succinct answer. 1. What is the ratio of the Net enrolment rate(%) of Lebanon in 2008 to that in 2011?
Make the answer very short. 0.99. What is the ratio of the Net enrolment rate(%) of Moldova in 2008 to that in 2011?
Give a very brief answer. 1.06. What is the ratio of the Net enrolment rate(%) in St. Lucia in 2008 to that in 2011?
Keep it short and to the point. 0.95. What is the ratio of the Net enrolment rate(%) in Lebanon in 2008 to that in 2012?
Ensure brevity in your answer.  1.02. What is the ratio of the Net enrolment rate(%) in Moldova in 2008 to that in 2012?
Offer a terse response. 1.06. What is the ratio of the Net enrolment rate(%) of St. Lucia in 2008 to that in 2012?
Provide a succinct answer. 0.95. What is the ratio of the Net enrolment rate(%) in Euro area in 2009 to that in 2010?
Keep it short and to the point. 1. What is the ratio of the Net enrolment rate(%) of Lebanon in 2009 to that in 2010?
Your answer should be compact. 1.03. What is the ratio of the Net enrolment rate(%) of Moldova in 2009 to that in 2010?
Give a very brief answer. 1.01. What is the ratio of the Net enrolment rate(%) of St. Lucia in 2009 to that in 2010?
Ensure brevity in your answer.  0.97. What is the ratio of the Net enrolment rate(%) of Euro area in 2009 to that in 2011?
Make the answer very short. 1. What is the ratio of the Net enrolment rate(%) of Moldova in 2009 to that in 2011?
Offer a very short reply. 1.02. What is the ratio of the Net enrolment rate(%) in Euro area in 2009 to that in 2012?
Keep it short and to the point. 1. What is the ratio of the Net enrolment rate(%) in Lebanon in 2009 to that in 2012?
Give a very brief answer. 1.03. What is the ratio of the Net enrolment rate(%) of St. Lucia in 2009 to that in 2012?
Ensure brevity in your answer.  1. What is the ratio of the Net enrolment rate(%) of Lebanon in 2010 to that in 2011?
Make the answer very short. 0.97. What is the ratio of the Net enrolment rate(%) in Moldova in 2010 to that in 2011?
Offer a very short reply. 1.01. What is the ratio of the Net enrolment rate(%) in St. Lucia in 2010 to that in 2011?
Make the answer very short. 1.02. What is the ratio of the Net enrolment rate(%) in Moldova in 2010 to that in 2012?
Your response must be concise. 1.01. What is the ratio of the Net enrolment rate(%) in St. Lucia in 2010 to that in 2012?
Your response must be concise. 1.03. What is the ratio of the Net enrolment rate(%) in Lebanon in 2011 to that in 2012?
Your answer should be very brief. 1.03. What is the ratio of the Net enrolment rate(%) in Moldova in 2011 to that in 2012?
Offer a very short reply. 1. What is the difference between the highest and the second highest Net enrolment rate(%) of Euro area?
Provide a succinct answer. 0.28. What is the difference between the highest and the second highest Net enrolment rate(%) of Lebanon?
Make the answer very short. 0.17. What is the difference between the highest and the second highest Net enrolment rate(%) of Moldova?
Give a very brief answer. 2.13. What is the difference between the highest and the second highest Net enrolment rate(%) of St. Lucia?
Make the answer very short. 1.81. What is the difference between the highest and the lowest Net enrolment rate(%) in Euro area?
Ensure brevity in your answer.  0.95. What is the difference between the highest and the lowest Net enrolment rate(%) in Lebanon?
Your answer should be very brief. 2.26. What is the difference between the highest and the lowest Net enrolment rate(%) in Moldova?
Your response must be concise. 4.71. What is the difference between the highest and the lowest Net enrolment rate(%) of St. Lucia?
Your answer should be compact. 22.14. 